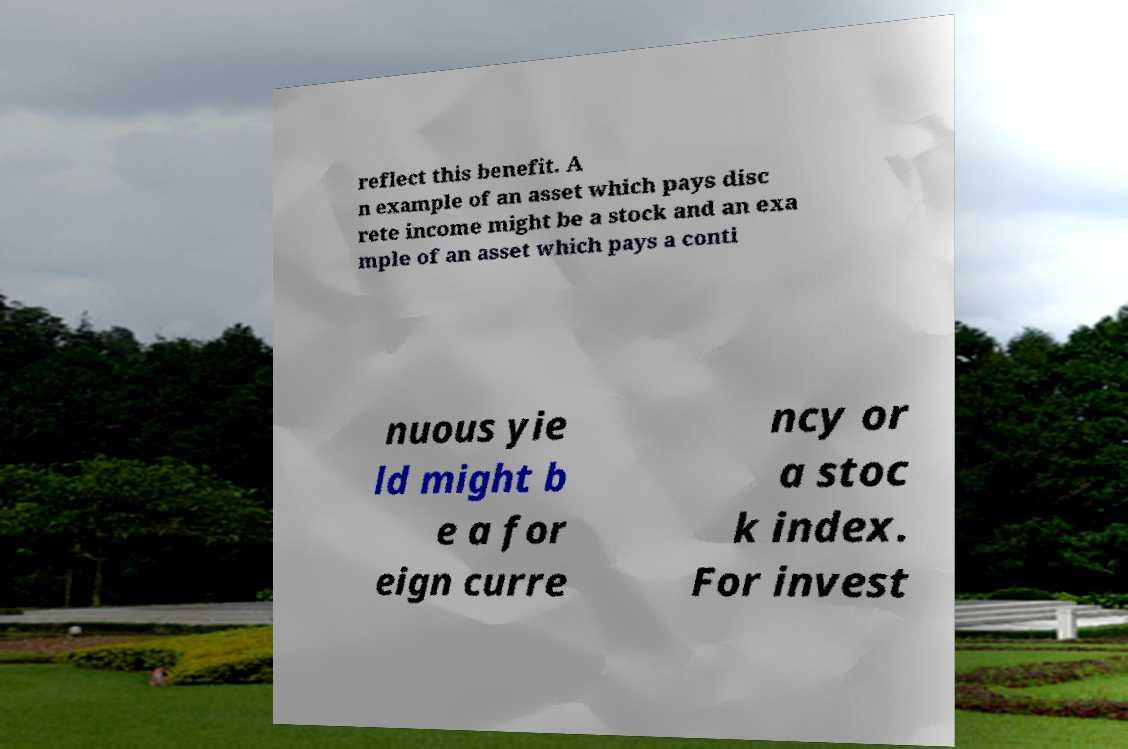For documentation purposes, I need the text within this image transcribed. Could you provide that? reflect this benefit. A n example of an asset which pays disc rete income might be a stock and an exa mple of an asset which pays a conti nuous yie ld might b e a for eign curre ncy or a stoc k index. For invest 